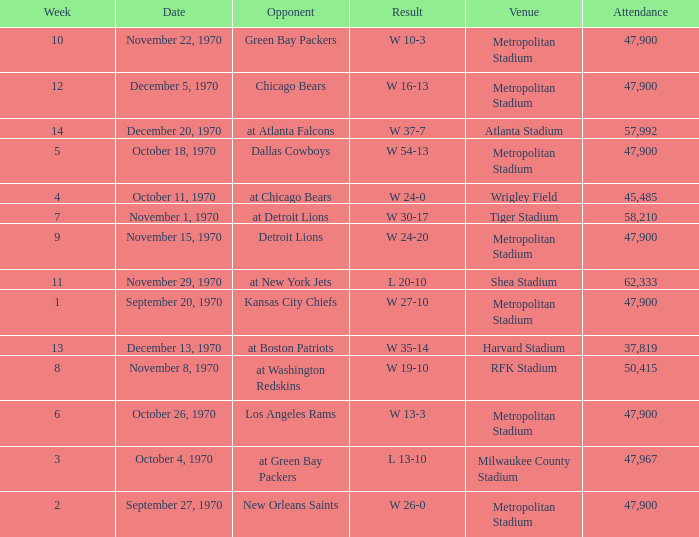How many people attended the game with a result of w 16-13 and a week earlier than 12? None. 